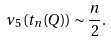Convert formula to latex. <formula><loc_0><loc_0><loc_500><loc_500>\nu _ { 5 } ( t _ { n } ( Q ) ) \sim \frac { n } { 2 } .</formula> 